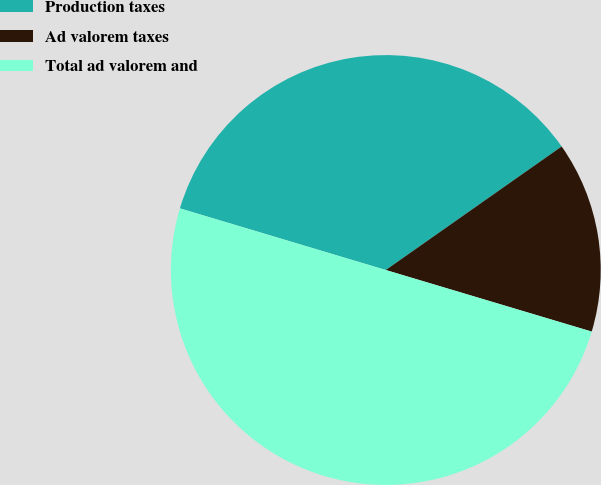Convert chart. <chart><loc_0><loc_0><loc_500><loc_500><pie_chart><fcel>Production taxes<fcel>Ad valorem taxes<fcel>Total ad valorem and<nl><fcel>35.62%<fcel>14.37%<fcel>50.0%<nl></chart> 